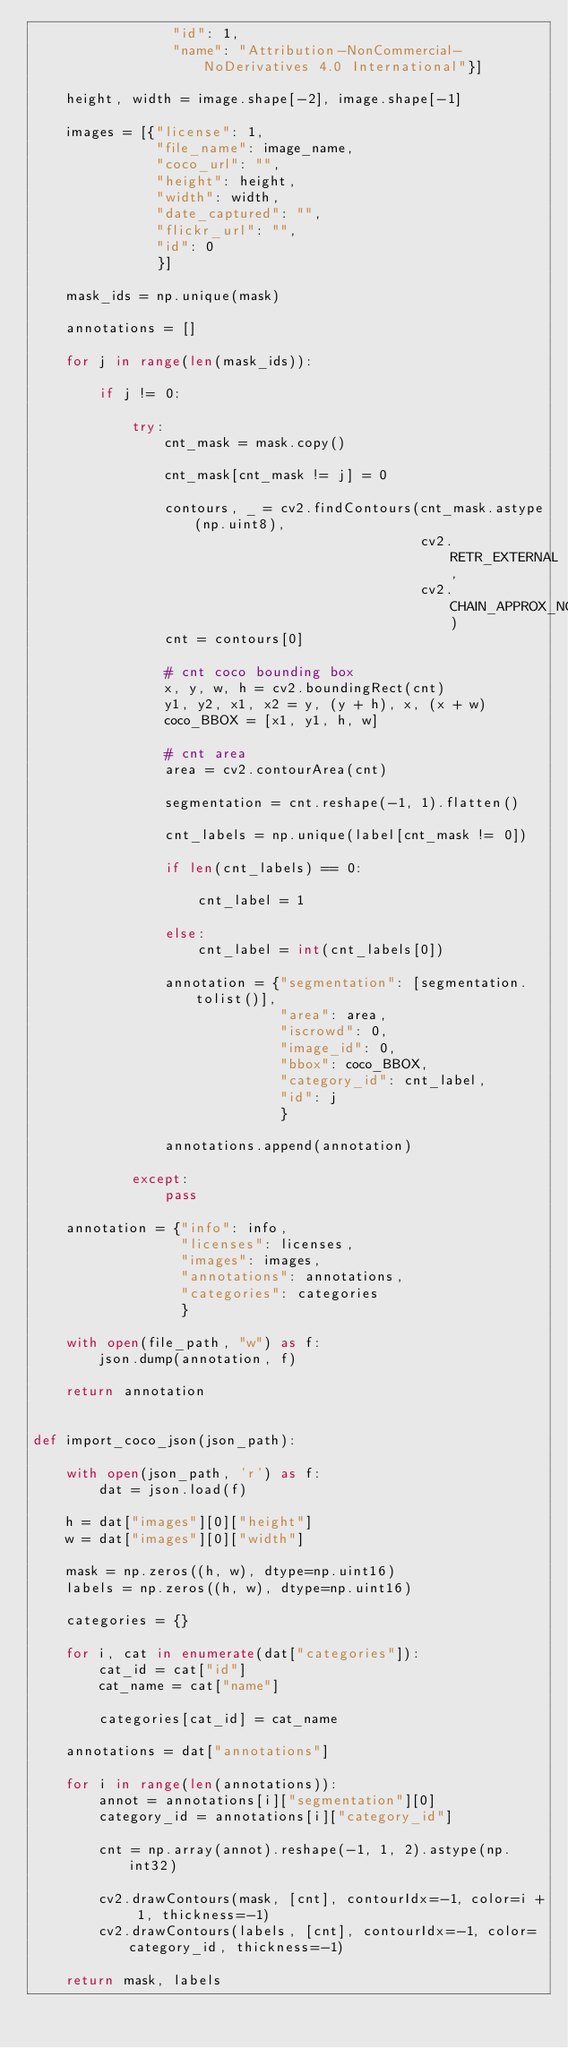<code> <loc_0><loc_0><loc_500><loc_500><_Python_>                 "id": 1,
                 "name": "Attribution-NonCommercial-NoDerivatives 4.0 International"}]

    height, width = image.shape[-2], image.shape[-1]

    images = [{"license": 1,
               "file_name": image_name,
               "coco_url": "",
               "height": height,
               "width": width,
               "date_captured": "",
               "flickr_url": "",
               "id": 0
               }]

    mask_ids = np.unique(mask)

    annotations = []

    for j in range(len(mask_ids)):

        if j != 0:

            try:
                cnt_mask = mask.copy()

                cnt_mask[cnt_mask != j] = 0

                contours, _ = cv2.findContours(cnt_mask.astype(np.uint8),
                                               cv2.RETR_EXTERNAL,
                                               cv2.CHAIN_APPROX_NONE)
                cnt = contours[0]

                # cnt coco bounding box
                x, y, w, h = cv2.boundingRect(cnt)
                y1, y2, x1, x2 = y, (y + h), x, (x + w)
                coco_BBOX = [x1, y1, h, w]

                # cnt area
                area = cv2.contourArea(cnt)

                segmentation = cnt.reshape(-1, 1).flatten()

                cnt_labels = np.unique(label[cnt_mask != 0])

                if len(cnt_labels) == 0:

                    cnt_label = 1

                else:
                    cnt_label = int(cnt_labels[0])

                annotation = {"segmentation": [segmentation.tolist()],
                              "area": area,
                              "iscrowd": 0,
                              "image_id": 0,
                              "bbox": coco_BBOX,
                              "category_id": cnt_label,
                              "id": j
                              }

                annotations.append(annotation)

            except:
                pass

    annotation = {"info": info,
                  "licenses": licenses,
                  "images": images,
                  "annotations": annotations,
                  "categories": categories
                  }

    with open(file_path, "w") as f:
        json.dump(annotation, f)

    return annotation


def import_coco_json(json_path):

    with open(json_path, 'r') as f:
        dat = json.load(f)

    h = dat["images"][0]["height"]
    w = dat["images"][0]["width"]

    mask = np.zeros((h, w), dtype=np.uint16)
    labels = np.zeros((h, w), dtype=np.uint16)

    categories = {}

    for i, cat in enumerate(dat["categories"]):
        cat_id = cat["id"]
        cat_name = cat["name"]

        categories[cat_id] = cat_name

    annotations = dat["annotations"]

    for i in range(len(annotations)):
        annot = annotations[i]["segmentation"][0]
        category_id = annotations[i]["category_id"]

        cnt = np.array(annot).reshape(-1, 1, 2).astype(np.int32)

        cv2.drawContours(mask, [cnt], contourIdx=-1, color=i + 1, thickness=-1)
        cv2.drawContours(labels, [cnt], contourIdx=-1, color=category_id, thickness=-1)

    return mask, labels</code> 